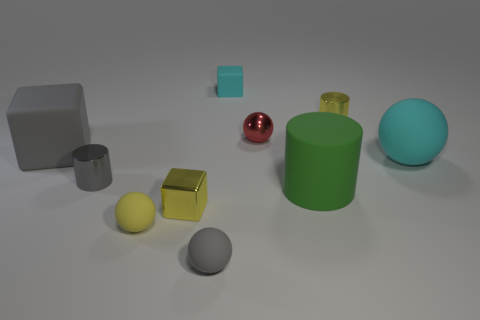Subtract 1 balls. How many balls are left? 3 Subtract all cylinders. How many objects are left? 7 Subtract 0 cyan cylinders. How many objects are left? 10 Subtract all large yellow matte objects. Subtract all metallic cylinders. How many objects are left? 8 Add 7 tiny cylinders. How many tiny cylinders are left? 9 Add 2 small gray objects. How many small gray objects exist? 4 